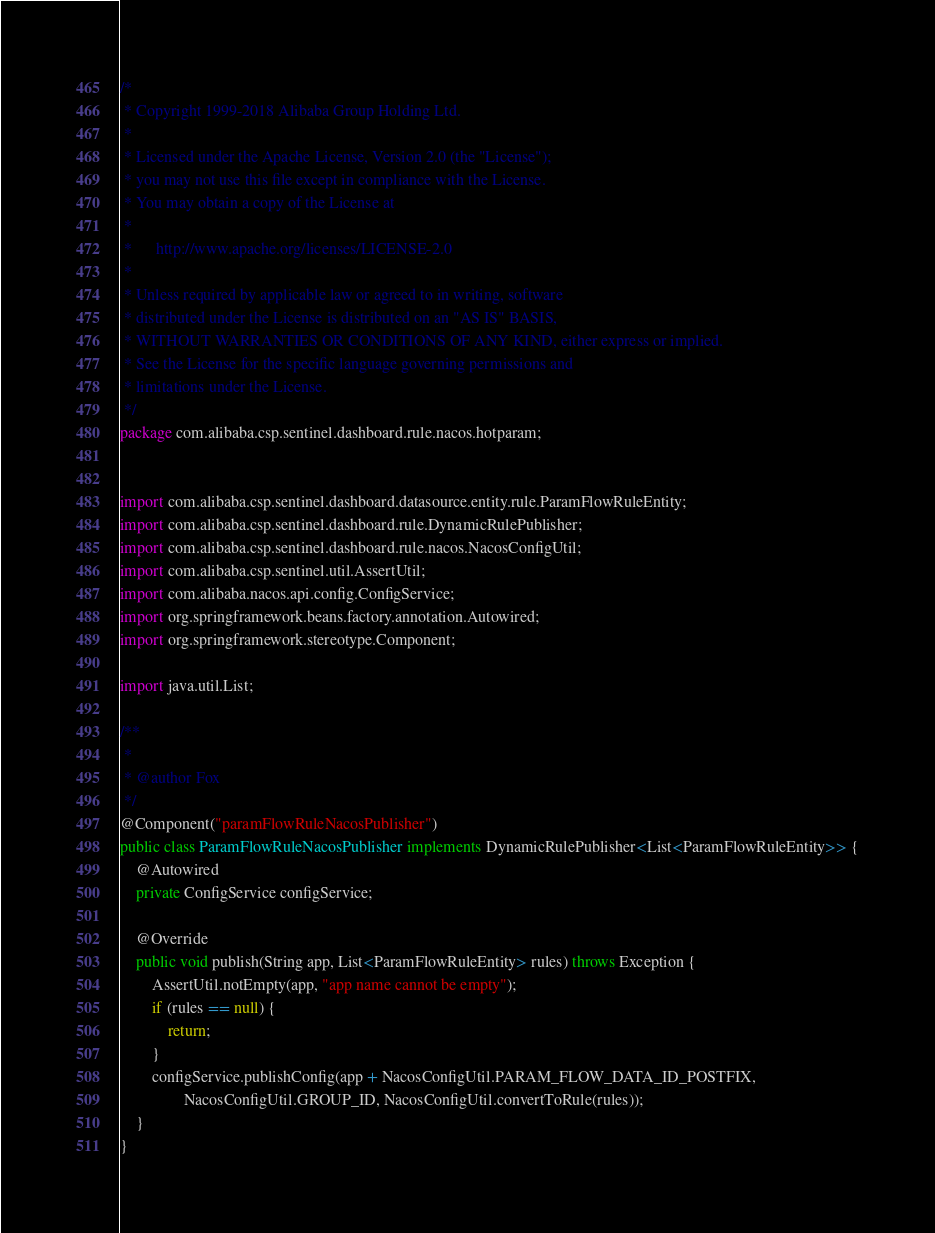Convert code to text. <code><loc_0><loc_0><loc_500><loc_500><_Java_>/*
 * Copyright 1999-2018 Alibaba Group Holding Ltd.
 *
 * Licensed under the Apache License, Version 2.0 (the "License");
 * you may not use this file except in compliance with the License.
 * You may obtain a copy of the License at
 *
 *      http://www.apache.org/licenses/LICENSE-2.0
 *
 * Unless required by applicable law or agreed to in writing, software
 * distributed under the License is distributed on an "AS IS" BASIS,
 * WITHOUT WARRANTIES OR CONDITIONS OF ANY KIND, either express or implied.
 * See the License for the specific language governing permissions and
 * limitations under the License.
 */
package com.alibaba.csp.sentinel.dashboard.rule.nacos.hotparam;


import com.alibaba.csp.sentinel.dashboard.datasource.entity.rule.ParamFlowRuleEntity;
import com.alibaba.csp.sentinel.dashboard.rule.DynamicRulePublisher;
import com.alibaba.csp.sentinel.dashboard.rule.nacos.NacosConfigUtil;
import com.alibaba.csp.sentinel.util.AssertUtil;
import com.alibaba.nacos.api.config.ConfigService;
import org.springframework.beans.factory.annotation.Autowired;
import org.springframework.stereotype.Component;

import java.util.List;

/**
 *
 * @author Fox
 */
@Component("paramFlowRuleNacosPublisher")
public class ParamFlowRuleNacosPublisher implements DynamicRulePublisher<List<ParamFlowRuleEntity>> {
    @Autowired
    private ConfigService configService;
    
    @Override
    public void publish(String app, List<ParamFlowRuleEntity> rules) throws Exception {
        AssertUtil.notEmpty(app, "app name cannot be empty");
        if (rules == null) {
            return;
        }
        configService.publishConfig(app + NacosConfigUtil.PARAM_FLOW_DATA_ID_POSTFIX,
                NacosConfigUtil.GROUP_ID, NacosConfigUtil.convertToRule(rules));
    }
}</code> 